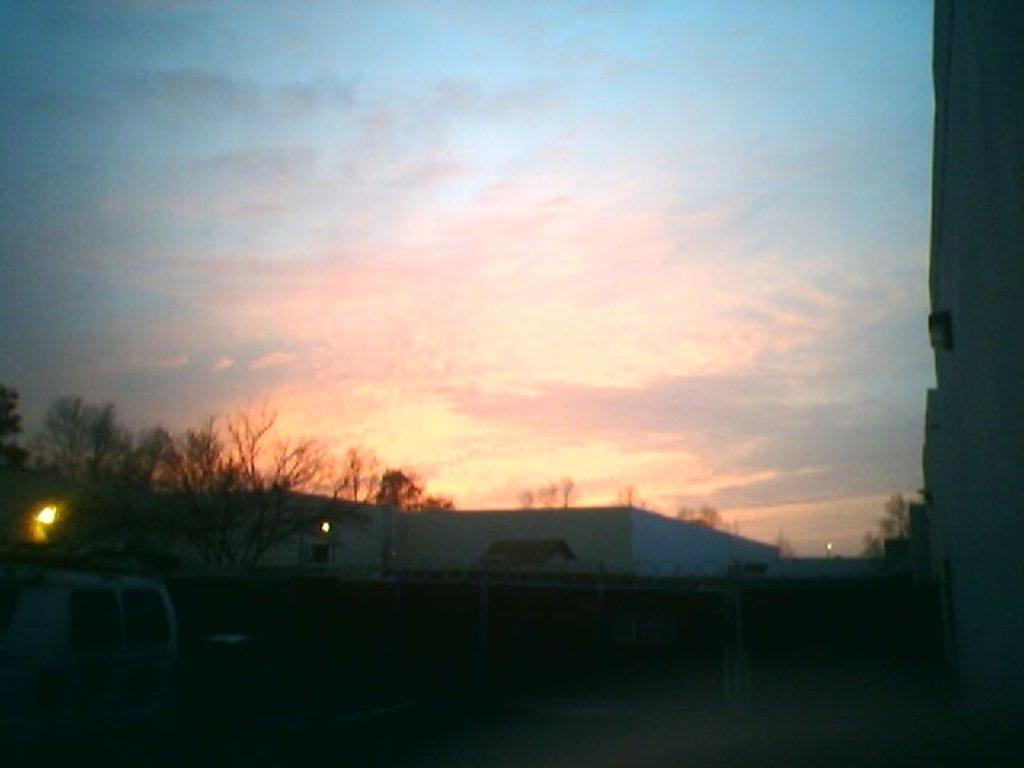What is the main subject of the image? A: There is a vehicle in the image. What can be seen in addition to the vehicle? There are lights, trees, buildings with windows, and the sky with clouds visible in the image. Can you describe the buildings in the image? The buildings have windows. What is visible in the background of the image? The sky with clouds is visible in the background of the image. What type of ornament is hanging from the vehicle in the image? There is no ornament hanging from the vehicle in the image. How is the oatmeal being served in the image? There is no oatmeal present in the image. 